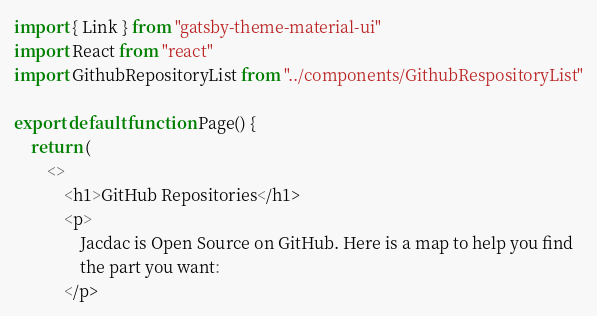Convert code to text. <code><loc_0><loc_0><loc_500><loc_500><_TypeScript_>import { Link } from "gatsby-theme-material-ui"
import React from "react"
import GithubRepositoryList from "../components/GithubRespositoryList"

export default function Page() {
    return (
        <>
            <h1>GitHub Repositories</h1>
            <p>
                Jacdac is Open Source on GitHub. Here is a map to help you find
                the part you want:
            </p></code> 